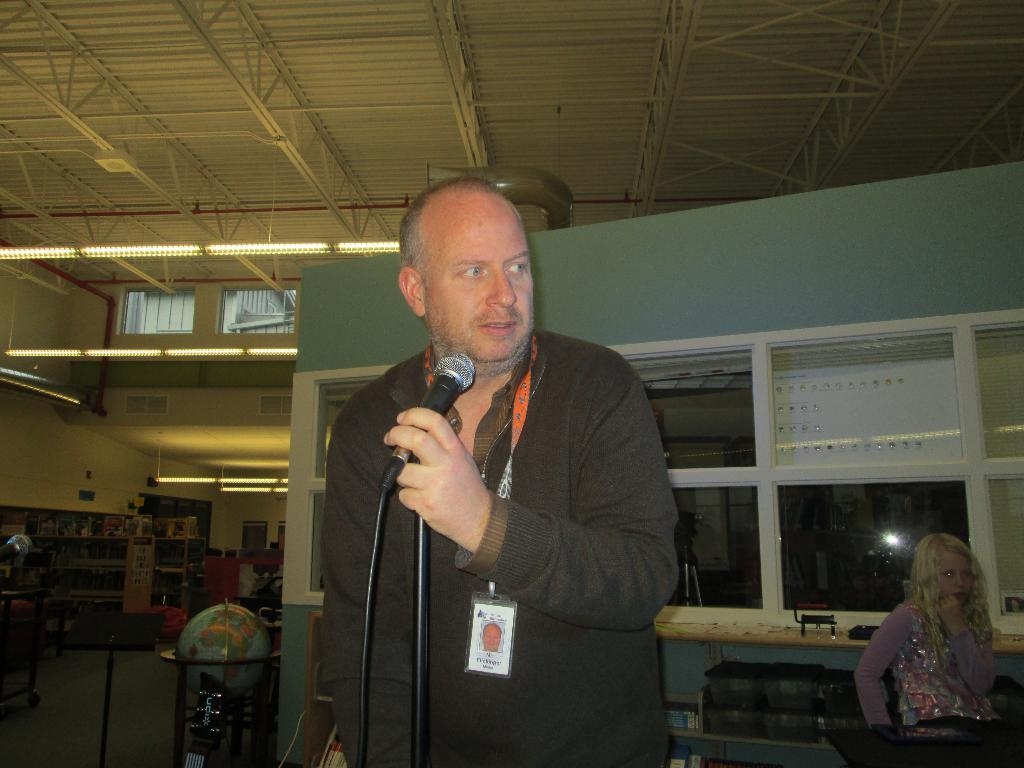How many people are present in the image? There are two people, a man and a woman, present in the image. What is the man wearing in the image? The man is wearing an ID card in the image. What is the man holding in the image? The man is holding a microphone in the image. What type of object can be seen in the room? There is a globe in the room. What type of furniture is present in the room? There are shelves in the room. What type of rock can be seen in the image? There is no rock present in the image. Can you describe the clouds visible in the image? There are no clouds visible in the image. 